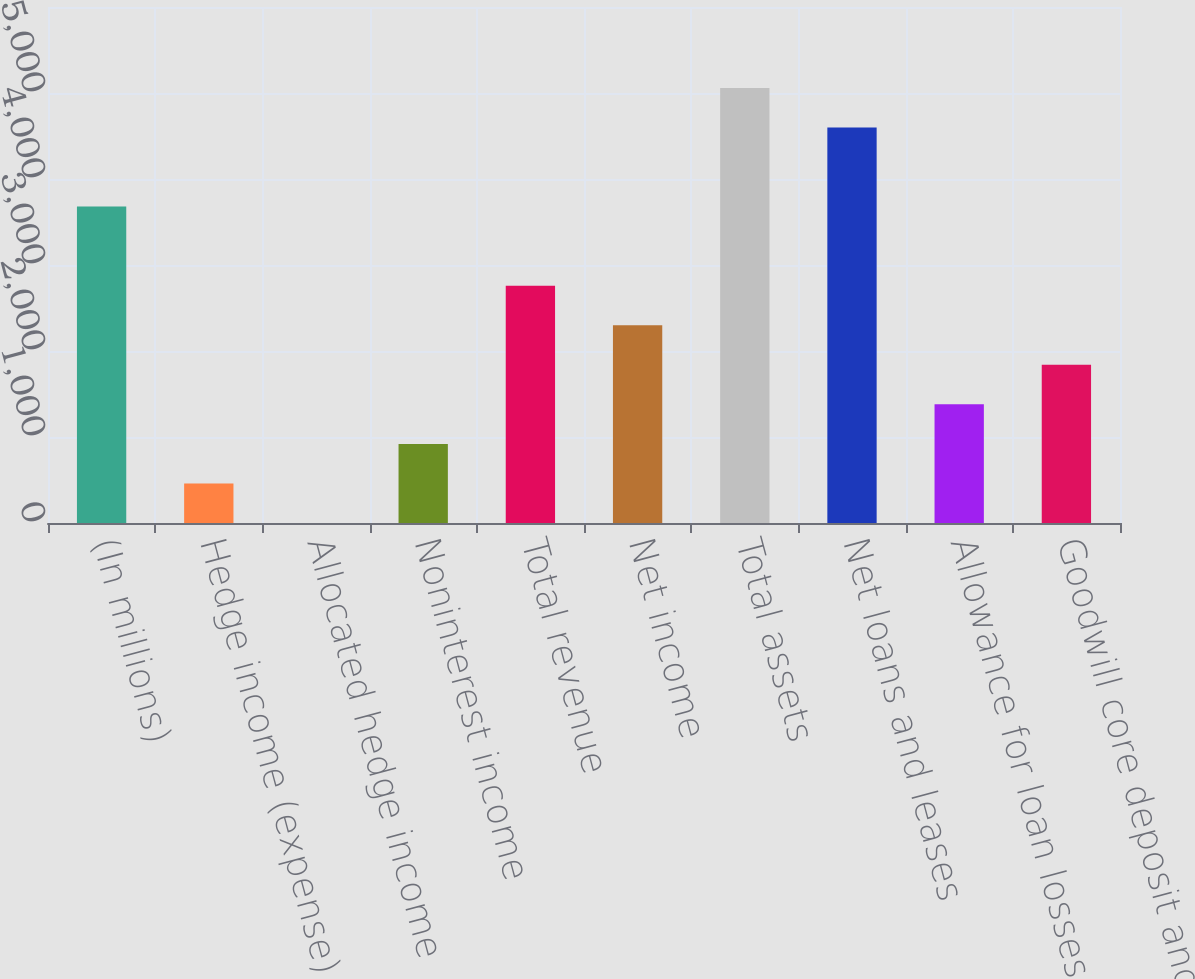Convert chart. <chart><loc_0><loc_0><loc_500><loc_500><bar_chart><fcel>(In millions)<fcel>Hedge income (expense)<fcel>Allocated hedge income<fcel>Noninterest income<fcel>Total revenue<fcel>Net income<fcel>Total assets<fcel>Net loans and leases<fcel>Allowance for loan losses<fcel>Goodwill core deposit and<nl><fcel>3679.24<fcel>460.08<fcel>0.2<fcel>919.96<fcel>2759.48<fcel>2299.6<fcel>5058.88<fcel>4599<fcel>1379.84<fcel>1839.72<nl></chart> 